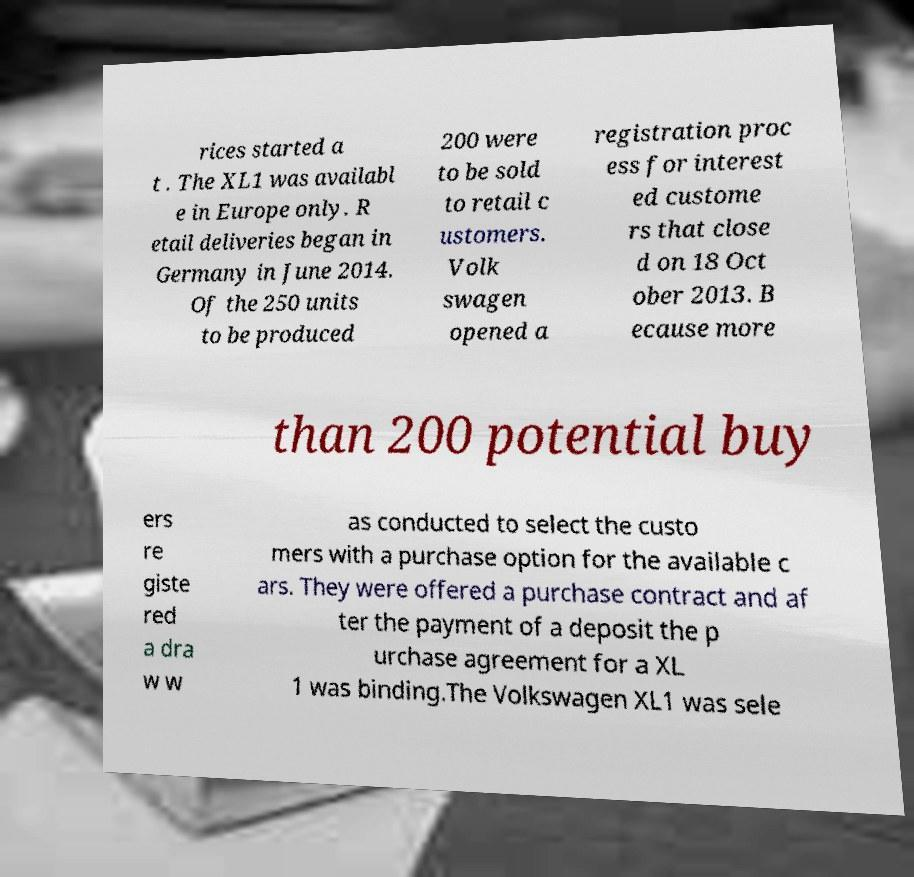I need the written content from this picture converted into text. Can you do that? rices started a t . The XL1 was availabl e in Europe only. R etail deliveries began in Germany in June 2014. Of the 250 units to be produced 200 were to be sold to retail c ustomers. Volk swagen opened a registration proc ess for interest ed custome rs that close d on 18 Oct ober 2013. B ecause more than 200 potential buy ers re giste red a dra w w as conducted to select the custo mers with a purchase option for the available c ars. They were offered a purchase contract and af ter the payment of a deposit the p urchase agreement for a XL 1 was binding.The Volkswagen XL1 was sele 